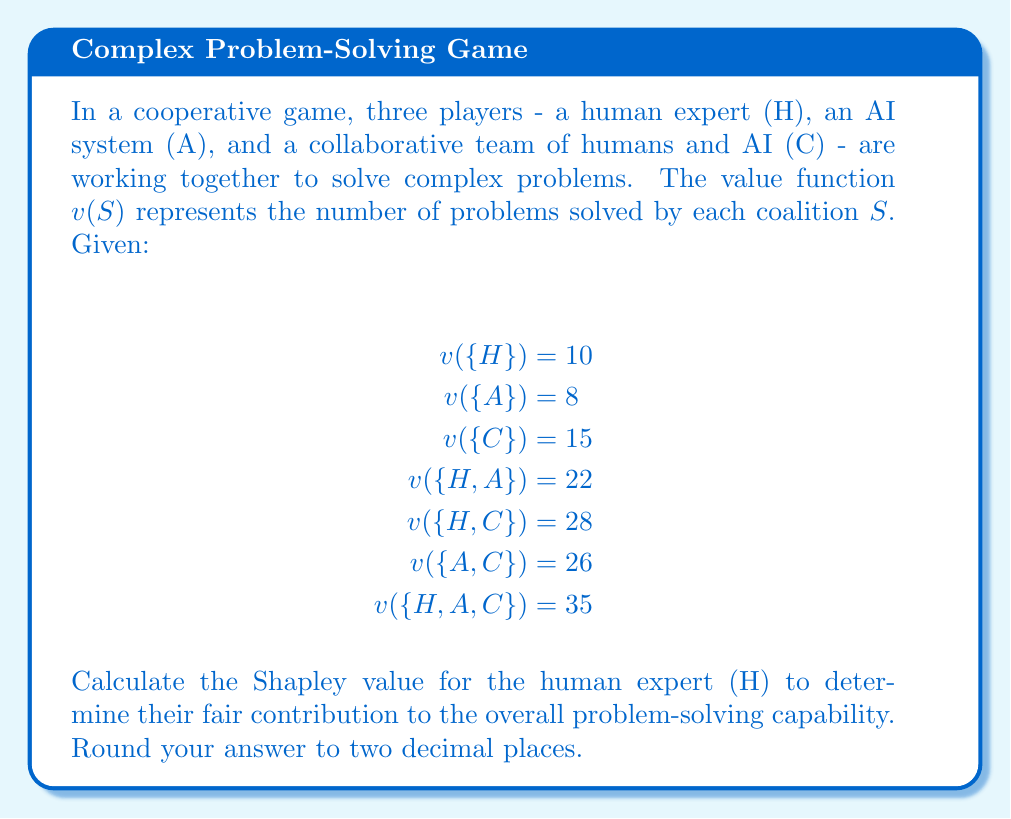Provide a solution to this math problem. To calculate the Shapley value for the human expert (H), we need to consider all possible coalitions and determine H's marginal contribution in each case. The Shapley value is the average of these marginal contributions across all possible orderings of players.

The Shapley value formula for player i is:

$$ \phi_i(v) = \sum_{S \subseteq N \setminus \{i\}} \frac{|S|!(n-|S|-1)!}{n!}[v(S \cup \{i\}) - v(S)] $$

Where:
- N is the set of all players
- n is the total number of players
- S is a subset of players not including i
- v(S) is the value function for coalition S

For the human expert (H), we need to calculate:

1. H's contribution when joining an empty coalition:
   $\frac{0!(3-0-1)!}{3!}[v(\{H\}) - v(\{\})] = \frac{1}{3}[10 - 0] = \frac{10}{3}$

2. H's contribution when joining A:
   $\frac{1!(3-1-1)!}{3!}[v(\{H,A\}) - v(\{A\})] = \frac{1}{6}[22 - 8] = \frac{14}{6}$

3. H's contribution when joining C:
   $\frac{1!(3-1-1)!}{3!}[v(\{H,C\}) - v(\{C\})] = \frac{1}{6}[28 - 15] = \frac{13}{6}$

4. H's contribution when joining {A,C}:
   $\frac{2!(3-2-1)!}{3!}[v(\{H,A,C\}) - v(\{A,C\})] = \frac{1}{3}[35 - 26] = 3$

The Shapley value for H is the sum of these contributions:

$$ \phi_H(v) = \frac{10}{3} + \frac{14}{6} + \frac{13}{6} + 3 = \frac{10}{3} + \frac{27}{6} + 3 = \frac{20}{6} + \frac{27}{6} + \frac{18}{6} = \frac{65}{6} = 10.8333... $$

Rounding to two decimal places, we get 10.83.
Answer: 10.83 